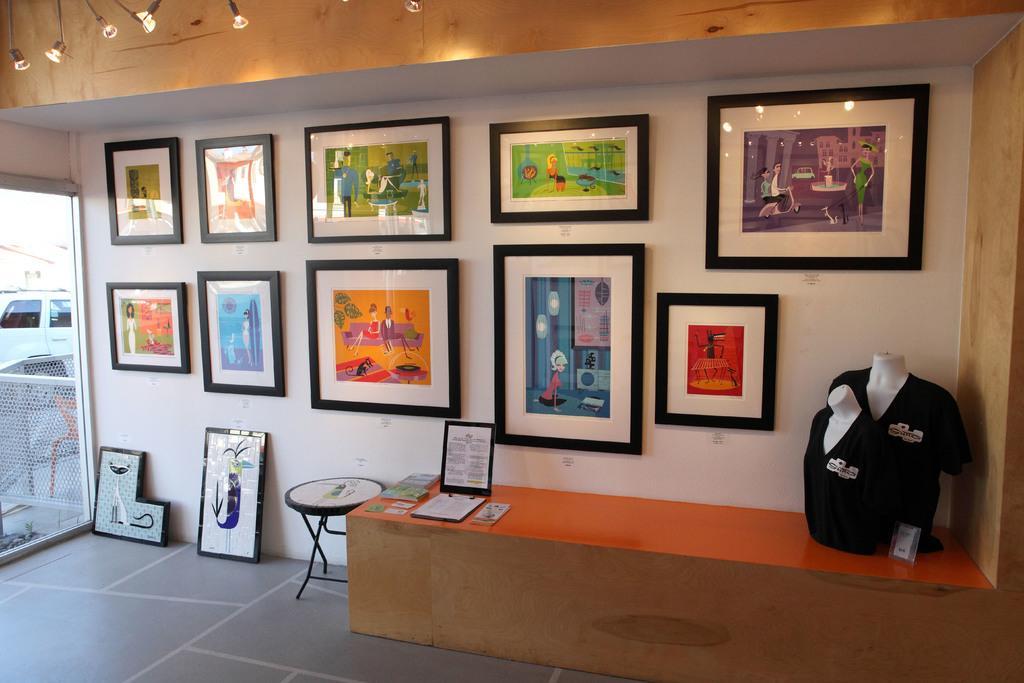Can you describe this image briefly? This picture is taken in a room. in the center there is a table, on the table there are mannequins towards the right, besides the table there is a chair. In the background there is a wall full of frames with the paintings. Towards the left there is a vehicle. 